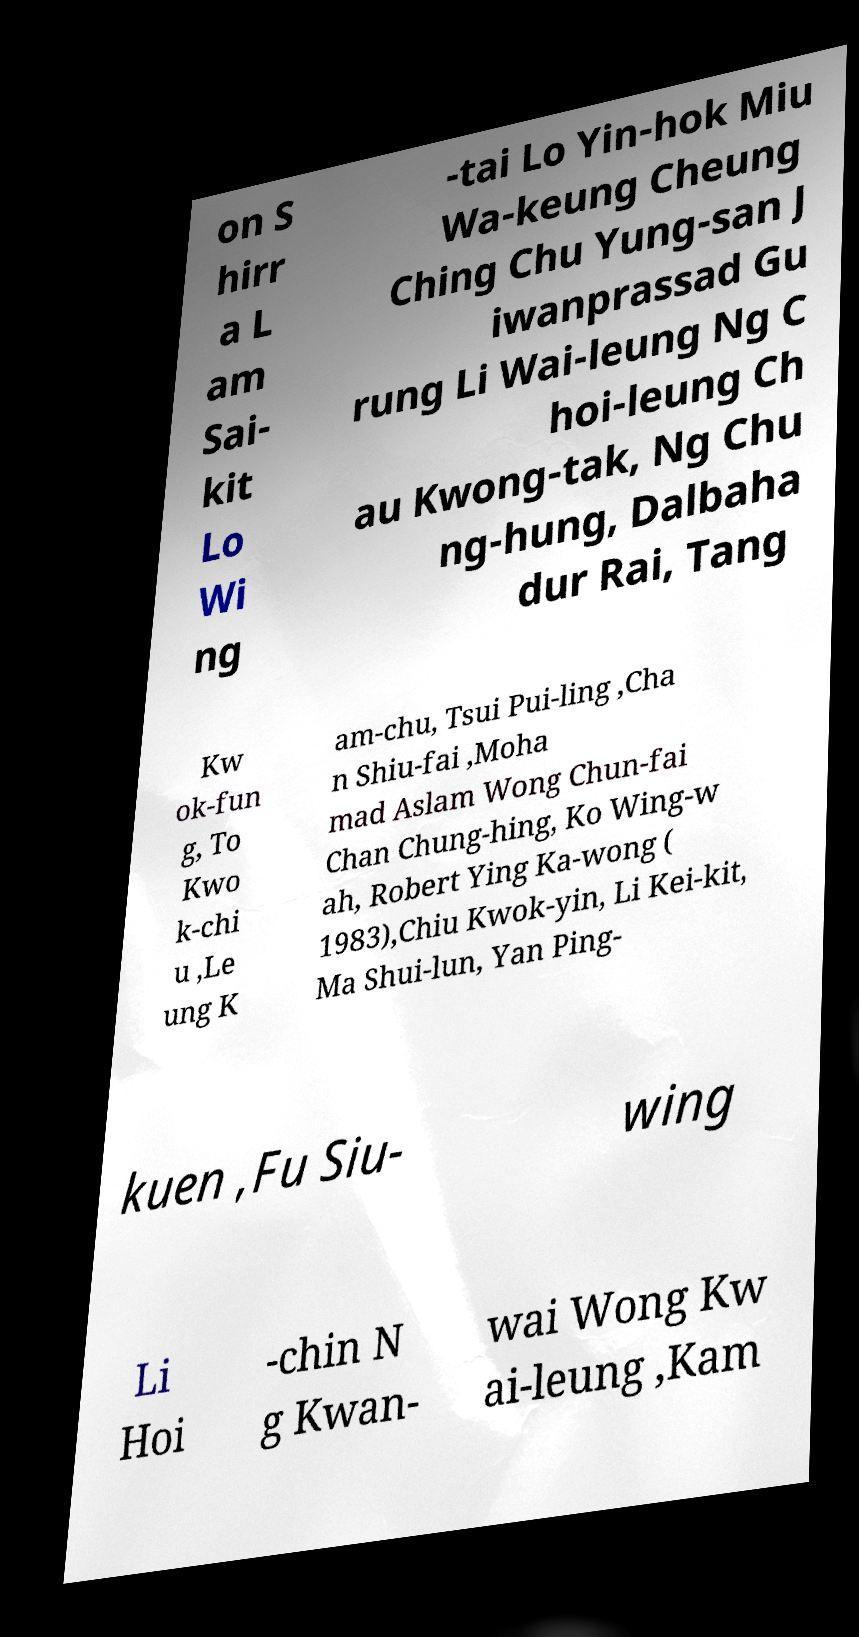I need the written content from this picture converted into text. Can you do that? on S hirr a L am Sai- kit Lo Wi ng -tai Lo Yin-hok Miu Wa-keung Cheung Ching Chu Yung-san J iwanprassad Gu rung Li Wai-leung Ng C hoi-leung Ch au Kwong-tak, Ng Chu ng-hung, Dalbaha dur Rai, Tang Kw ok-fun g, To Kwo k-chi u ,Le ung K am-chu, Tsui Pui-ling ,Cha n Shiu-fai ,Moha mad Aslam Wong Chun-fai Chan Chung-hing, Ko Wing-w ah, Robert Ying Ka-wong ( 1983),Chiu Kwok-yin, Li Kei-kit, Ma Shui-lun, Yan Ping- kuen ,Fu Siu- wing Li Hoi -chin N g Kwan- wai Wong Kw ai-leung ,Kam 